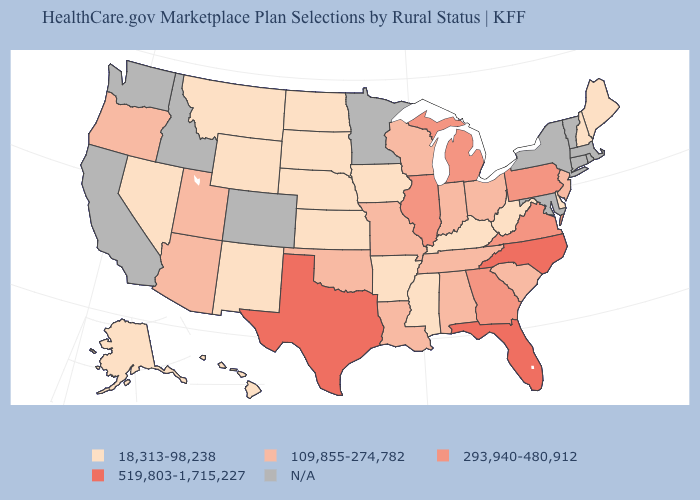What is the highest value in the USA?
Write a very short answer. 519,803-1,715,227. Name the states that have a value in the range 109,855-274,782?
Concise answer only. Alabama, Arizona, Indiana, Louisiana, Missouri, New Jersey, Ohio, Oklahoma, Oregon, South Carolina, Tennessee, Utah, Wisconsin. What is the lowest value in the USA?
Write a very short answer. 18,313-98,238. Does the map have missing data?
Keep it brief. Yes. What is the value of Pennsylvania?
Be succinct. 293,940-480,912. Does Illinois have the highest value in the MidWest?
Quick response, please. Yes. Does the first symbol in the legend represent the smallest category?
Answer briefly. Yes. Name the states that have a value in the range 18,313-98,238?
Write a very short answer. Alaska, Arkansas, Delaware, Hawaii, Iowa, Kansas, Kentucky, Maine, Mississippi, Montana, Nebraska, Nevada, New Hampshire, New Mexico, North Dakota, South Dakota, West Virginia, Wyoming. Does the map have missing data?
Write a very short answer. Yes. What is the highest value in states that border Wisconsin?
Short answer required. 293,940-480,912. Name the states that have a value in the range 519,803-1,715,227?
Keep it brief. Florida, North Carolina, Texas. Name the states that have a value in the range N/A?
Give a very brief answer. California, Colorado, Connecticut, Idaho, Maryland, Massachusetts, Minnesota, New York, Rhode Island, Vermont, Washington. How many symbols are there in the legend?
Answer briefly. 5. Name the states that have a value in the range 109,855-274,782?
Quick response, please. Alabama, Arizona, Indiana, Louisiana, Missouri, New Jersey, Ohio, Oklahoma, Oregon, South Carolina, Tennessee, Utah, Wisconsin. What is the value of North Carolina?
Quick response, please. 519,803-1,715,227. 